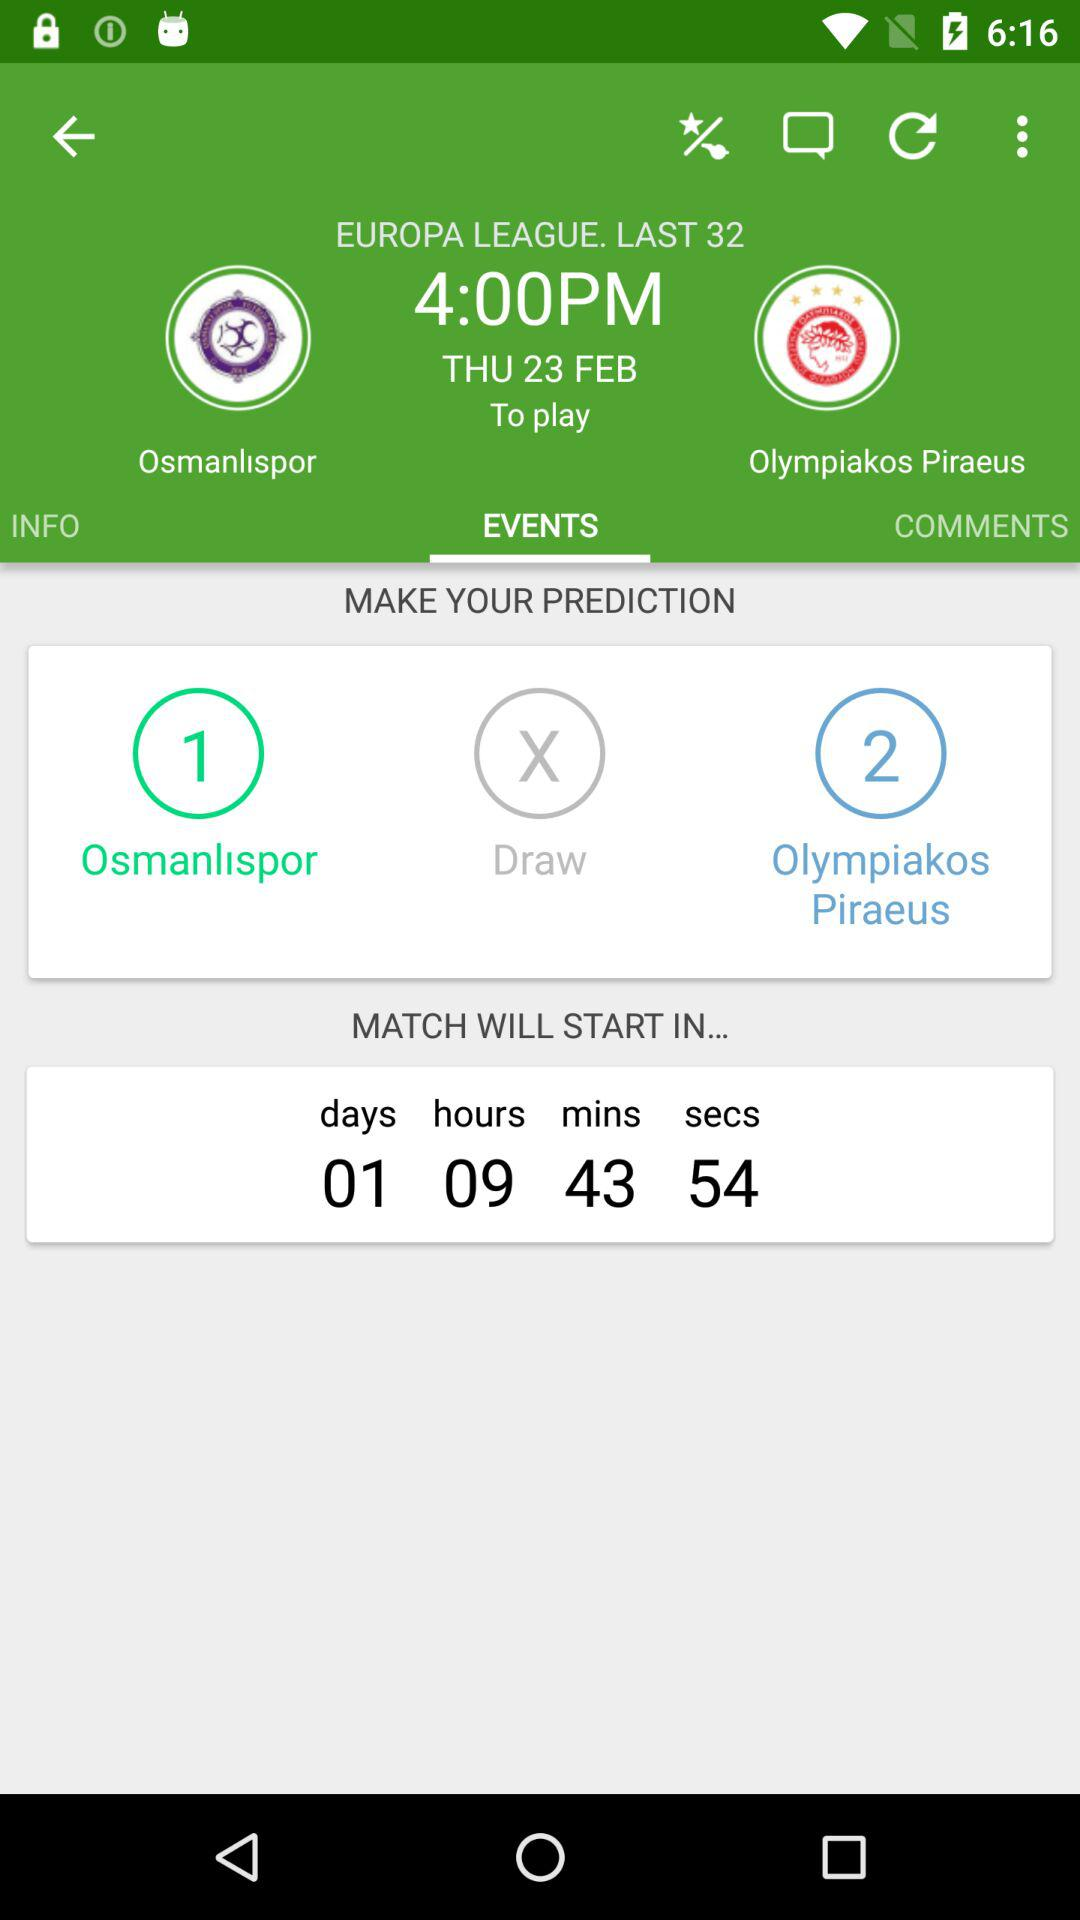What is the time of the match? The time is 4 PM. 